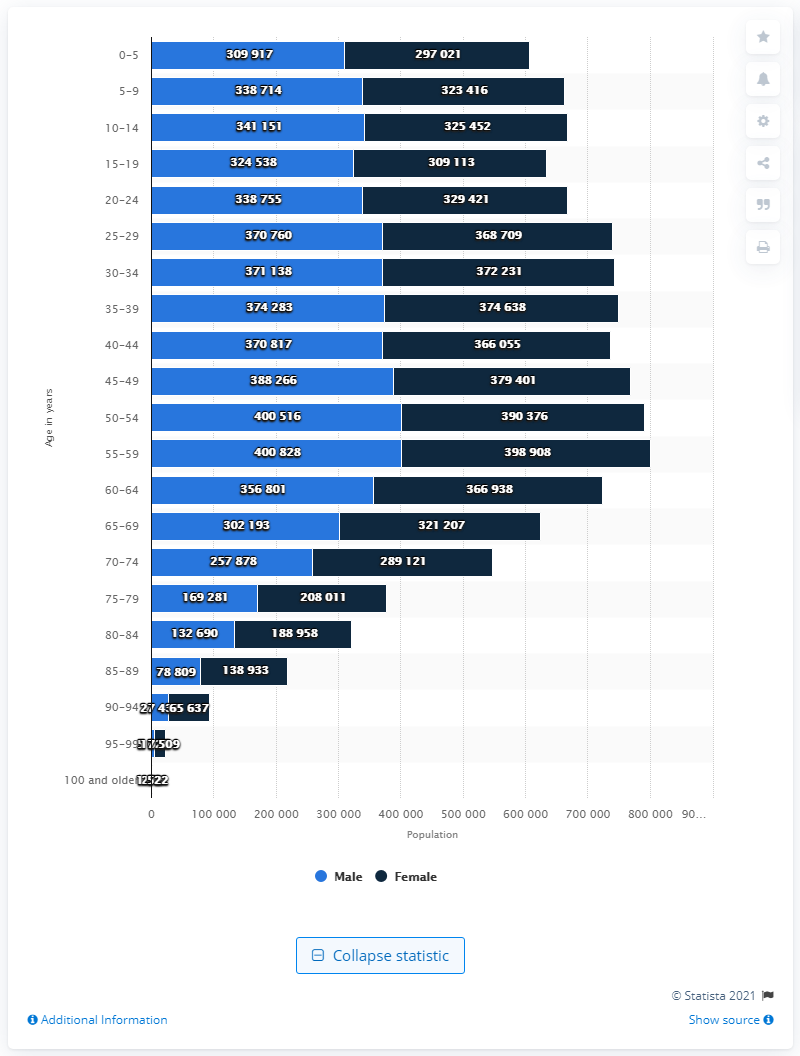Outline some significant characteristics in this image. In 2020, there were approximately 400,516 male inhabitants between the ages of 55 and 59. 